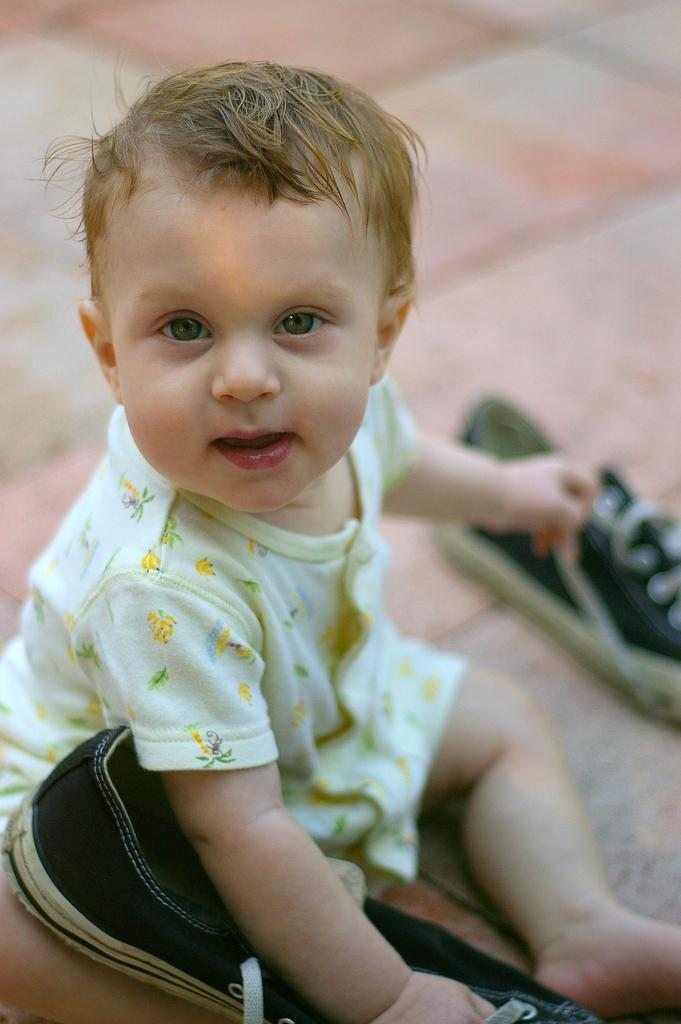What is the main subject of the image? The main subject of the image is a kid. Where is the kid located in the image? The kid is sitting on the floor. What is the kid holding in the image? The kid is holding a shoe. What type of camera can be seen in the image? There is no camera present in the image. Is the kid playing with a ball in the image? There is no ball present in the image. 